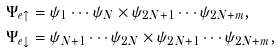<formula> <loc_0><loc_0><loc_500><loc_500>\Psi _ { e \uparrow } & = \psi _ { 1 } \cdots \psi _ { N } \times \psi _ { 2 N + 1 } \cdots \psi _ { 2 N + m } , \\ \Psi _ { e \downarrow } & = \psi _ { N + 1 } \cdots \psi _ { 2 N } \times \psi _ { 2 N + 1 } \cdots \psi _ { 2 N + m } ,</formula> 